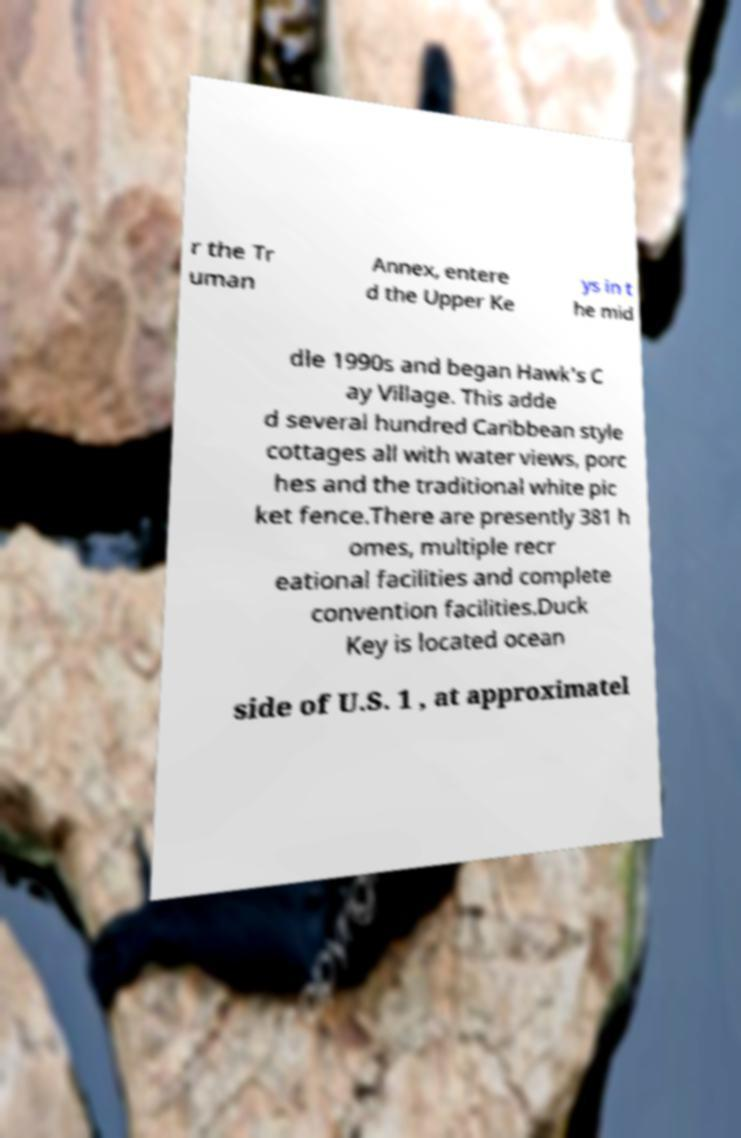There's text embedded in this image that I need extracted. Can you transcribe it verbatim? r the Tr uman Annex, entere d the Upper Ke ys in t he mid dle 1990s and began Hawk's C ay Village. This adde d several hundred Caribbean style cottages all with water views, porc hes and the traditional white pic ket fence.There are presently 381 h omes, multiple recr eational facilities and complete convention facilities.Duck Key is located ocean side of U.S. 1 , at approximatel 